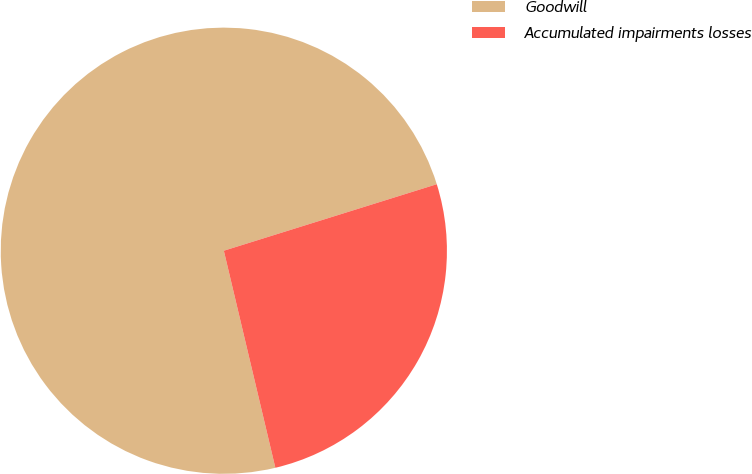<chart> <loc_0><loc_0><loc_500><loc_500><pie_chart><fcel>Goodwill<fcel>Accumulated impairments losses<nl><fcel>73.89%<fcel>26.11%<nl></chart> 